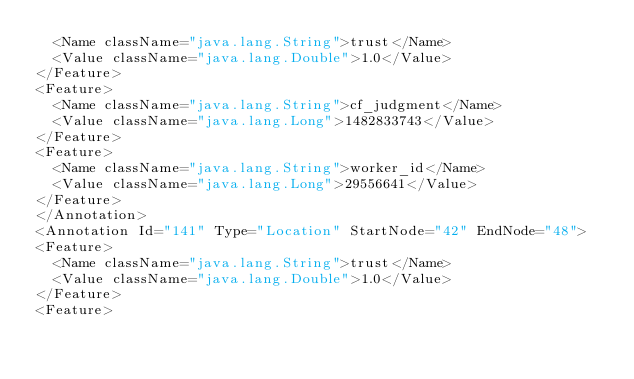<code> <loc_0><loc_0><loc_500><loc_500><_XML_>  <Name className="java.lang.String">trust</Name>
  <Value className="java.lang.Double">1.0</Value>
</Feature>
<Feature>
  <Name className="java.lang.String">cf_judgment</Name>
  <Value className="java.lang.Long">1482833743</Value>
</Feature>
<Feature>
  <Name className="java.lang.String">worker_id</Name>
  <Value className="java.lang.Long">29556641</Value>
</Feature>
</Annotation>
<Annotation Id="141" Type="Location" StartNode="42" EndNode="48">
<Feature>
  <Name className="java.lang.String">trust</Name>
  <Value className="java.lang.Double">1.0</Value>
</Feature>
<Feature></code> 